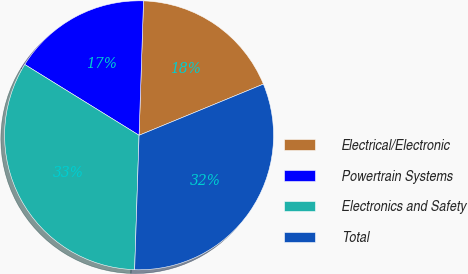Convert chart. <chart><loc_0><loc_0><loc_500><loc_500><pie_chart><fcel>Electrical/Electronic<fcel>Powertrain Systems<fcel>Electronics and Safety<fcel>Total<nl><fcel>18.26%<fcel>16.7%<fcel>33.3%<fcel>31.74%<nl></chart> 